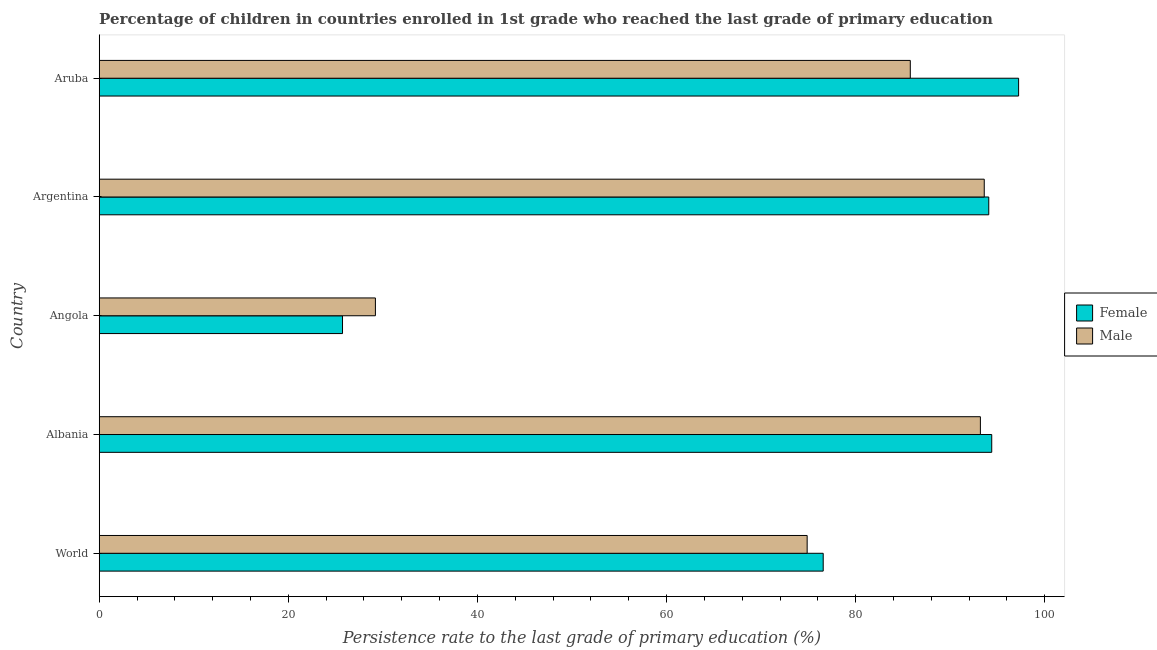Are the number of bars per tick equal to the number of legend labels?
Offer a very short reply. Yes. How many bars are there on the 5th tick from the top?
Ensure brevity in your answer.  2. How many bars are there on the 4th tick from the bottom?
Your response must be concise. 2. In how many cases, is the number of bars for a given country not equal to the number of legend labels?
Make the answer very short. 0. What is the persistence rate of female students in Albania?
Make the answer very short. 94.39. Across all countries, what is the maximum persistence rate of female students?
Give a very brief answer. 97.23. Across all countries, what is the minimum persistence rate of female students?
Provide a short and direct response. 25.73. In which country was the persistence rate of male students maximum?
Offer a terse response. Argentina. In which country was the persistence rate of male students minimum?
Make the answer very short. Angola. What is the total persistence rate of male students in the graph?
Ensure brevity in your answer.  376.64. What is the difference between the persistence rate of male students in Albania and that in World?
Provide a short and direct response. 18.32. What is the difference between the persistence rate of male students in World and the persistence rate of female students in Albania?
Keep it short and to the point. -19.52. What is the average persistence rate of female students per country?
Your response must be concise. 77.6. What is the difference between the persistence rate of male students and persistence rate of female students in Aruba?
Your answer should be very brief. -11.46. In how many countries, is the persistence rate of male students greater than 84 %?
Your answer should be very brief. 3. What is the ratio of the persistence rate of female students in Argentina to that in World?
Ensure brevity in your answer.  1.23. Is the difference between the persistence rate of male students in Argentina and Aruba greater than the difference between the persistence rate of female students in Argentina and Aruba?
Your answer should be very brief. Yes. What is the difference between the highest and the second highest persistence rate of female students?
Offer a very short reply. 2.84. What is the difference between the highest and the lowest persistence rate of female students?
Provide a short and direct response. 71.5. In how many countries, is the persistence rate of female students greater than the average persistence rate of female students taken over all countries?
Your response must be concise. 3. Is the sum of the persistence rate of male students in Albania and Angola greater than the maximum persistence rate of female students across all countries?
Provide a succinct answer. Yes. How many countries are there in the graph?
Your answer should be compact. 5. What is the difference between two consecutive major ticks on the X-axis?
Provide a succinct answer. 20. Does the graph contain any zero values?
Keep it short and to the point. No. Does the graph contain grids?
Make the answer very short. No. What is the title of the graph?
Provide a short and direct response. Percentage of children in countries enrolled in 1st grade who reached the last grade of primary education. What is the label or title of the X-axis?
Offer a very short reply. Persistence rate to the last grade of primary education (%). What is the Persistence rate to the last grade of primary education (%) in Female in World?
Provide a short and direct response. 76.57. What is the Persistence rate to the last grade of primary education (%) in Male in World?
Ensure brevity in your answer.  74.87. What is the Persistence rate to the last grade of primary education (%) of Female in Albania?
Offer a very short reply. 94.39. What is the Persistence rate to the last grade of primary education (%) in Male in Albania?
Provide a short and direct response. 93.19. What is the Persistence rate to the last grade of primary education (%) of Female in Angola?
Keep it short and to the point. 25.73. What is the Persistence rate to the last grade of primary education (%) of Male in Angola?
Your answer should be very brief. 29.21. What is the Persistence rate to the last grade of primary education (%) in Female in Argentina?
Give a very brief answer. 94.08. What is the Persistence rate to the last grade of primary education (%) of Male in Argentina?
Provide a short and direct response. 93.6. What is the Persistence rate to the last grade of primary education (%) in Female in Aruba?
Provide a succinct answer. 97.23. What is the Persistence rate to the last grade of primary education (%) in Male in Aruba?
Keep it short and to the point. 85.78. Across all countries, what is the maximum Persistence rate to the last grade of primary education (%) in Female?
Your response must be concise. 97.23. Across all countries, what is the maximum Persistence rate to the last grade of primary education (%) in Male?
Provide a short and direct response. 93.6. Across all countries, what is the minimum Persistence rate to the last grade of primary education (%) of Female?
Provide a succinct answer. 25.73. Across all countries, what is the minimum Persistence rate to the last grade of primary education (%) in Male?
Keep it short and to the point. 29.21. What is the total Persistence rate to the last grade of primary education (%) of Female in the graph?
Your answer should be compact. 387.99. What is the total Persistence rate to the last grade of primary education (%) in Male in the graph?
Keep it short and to the point. 376.64. What is the difference between the Persistence rate to the last grade of primary education (%) in Female in World and that in Albania?
Give a very brief answer. -17.82. What is the difference between the Persistence rate to the last grade of primary education (%) of Male in World and that in Albania?
Your answer should be compact. -18.32. What is the difference between the Persistence rate to the last grade of primary education (%) in Female in World and that in Angola?
Your response must be concise. 50.83. What is the difference between the Persistence rate to the last grade of primary education (%) of Male in World and that in Angola?
Ensure brevity in your answer.  45.66. What is the difference between the Persistence rate to the last grade of primary education (%) of Female in World and that in Argentina?
Offer a very short reply. -17.51. What is the difference between the Persistence rate to the last grade of primary education (%) in Male in World and that in Argentina?
Make the answer very short. -18.73. What is the difference between the Persistence rate to the last grade of primary education (%) of Female in World and that in Aruba?
Your answer should be compact. -20.67. What is the difference between the Persistence rate to the last grade of primary education (%) in Male in World and that in Aruba?
Offer a terse response. -10.91. What is the difference between the Persistence rate to the last grade of primary education (%) of Female in Albania and that in Angola?
Ensure brevity in your answer.  68.66. What is the difference between the Persistence rate to the last grade of primary education (%) in Male in Albania and that in Angola?
Provide a succinct answer. 63.98. What is the difference between the Persistence rate to the last grade of primary education (%) in Female in Albania and that in Argentina?
Ensure brevity in your answer.  0.31. What is the difference between the Persistence rate to the last grade of primary education (%) of Male in Albania and that in Argentina?
Offer a very short reply. -0.41. What is the difference between the Persistence rate to the last grade of primary education (%) of Female in Albania and that in Aruba?
Give a very brief answer. -2.84. What is the difference between the Persistence rate to the last grade of primary education (%) of Male in Albania and that in Aruba?
Provide a short and direct response. 7.41. What is the difference between the Persistence rate to the last grade of primary education (%) in Female in Angola and that in Argentina?
Make the answer very short. -68.34. What is the difference between the Persistence rate to the last grade of primary education (%) of Male in Angola and that in Argentina?
Your answer should be compact. -64.39. What is the difference between the Persistence rate to the last grade of primary education (%) in Female in Angola and that in Aruba?
Your response must be concise. -71.5. What is the difference between the Persistence rate to the last grade of primary education (%) in Male in Angola and that in Aruba?
Offer a terse response. -56.57. What is the difference between the Persistence rate to the last grade of primary education (%) of Female in Argentina and that in Aruba?
Your answer should be very brief. -3.16. What is the difference between the Persistence rate to the last grade of primary education (%) in Male in Argentina and that in Aruba?
Ensure brevity in your answer.  7.82. What is the difference between the Persistence rate to the last grade of primary education (%) in Female in World and the Persistence rate to the last grade of primary education (%) in Male in Albania?
Your response must be concise. -16.62. What is the difference between the Persistence rate to the last grade of primary education (%) in Female in World and the Persistence rate to the last grade of primary education (%) in Male in Angola?
Provide a succinct answer. 47.36. What is the difference between the Persistence rate to the last grade of primary education (%) of Female in World and the Persistence rate to the last grade of primary education (%) of Male in Argentina?
Your answer should be compact. -17.03. What is the difference between the Persistence rate to the last grade of primary education (%) in Female in World and the Persistence rate to the last grade of primary education (%) in Male in Aruba?
Your answer should be very brief. -9.21. What is the difference between the Persistence rate to the last grade of primary education (%) in Female in Albania and the Persistence rate to the last grade of primary education (%) in Male in Angola?
Ensure brevity in your answer.  65.18. What is the difference between the Persistence rate to the last grade of primary education (%) in Female in Albania and the Persistence rate to the last grade of primary education (%) in Male in Argentina?
Provide a short and direct response. 0.79. What is the difference between the Persistence rate to the last grade of primary education (%) of Female in Albania and the Persistence rate to the last grade of primary education (%) of Male in Aruba?
Provide a short and direct response. 8.61. What is the difference between the Persistence rate to the last grade of primary education (%) in Female in Angola and the Persistence rate to the last grade of primary education (%) in Male in Argentina?
Your answer should be very brief. -67.87. What is the difference between the Persistence rate to the last grade of primary education (%) in Female in Angola and the Persistence rate to the last grade of primary education (%) in Male in Aruba?
Provide a short and direct response. -60.05. What is the difference between the Persistence rate to the last grade of primary education (%) in Female in Argentina and the Persistence rate to the last grade of primary education (%) in Male in Aruba?
Offer a very short reply. 8.3. What is the average Persistence rate to the last grade of primary education (%) in Female per country?
Provide a succinct answer. 77.6. What is the average Persistence rate to the last grade of primary education (%) of Male per country?
Your answer should be compact. 75.33. What is the difference between the Persistence rate to the last grade of primary education (%) of Female and Persistence rate to the last grade of primary education (%) of Male in World?
Ensure brevity in your answer.  1.7. What is the difference between the Persistence rate to the last grade of primary education (%) in Female and Persistence rate to the last grade of primary education (%) in Male in Albania?
Provide a succinct answer. 1.2. What is the difference between the Persistence rate to the last grade of primary education (%) of Female and Persistence rate to the last grade of primary education (%) of Male in Angola?
Provide a short and direct response. -3.48. What is the difference between the Persistence rate to the last grade of primary education (%) of Female and Persistence rate to the last grade of primary education (%) of Male in Argentina?
Make the answer very short. 0.48. What is the difference between the Persistence rate to the last grade of primary education (%) of Female and Persistence rate to the last grade of primary education (%) of Male in Aruba?
Your response must be concise. 11.46. What is the ratio of the Persistence rate to the last grade of primary education (%) in Female in World to that in Albania?
Give a very brief answer. 0.81. What is the ratio of the Persistence rate to the last grade of primary education (%) in Male in World to that in Albania?
Provide a succinct answer. 0.8. What is the ratio of the Persistence rate to the last grade of primary education (%) in Female in World to that in Angola?
Your answer should be compact. 2.98. What is the ratio of the Persistence rate to the last grade of primary education (%) of Male in World to that in Angola?
Give a very brief answer. 2.56. What is the ratio of the Persistence rate to the last grade of primary education (%) in Female in World to that in Argentina?
Give a very brief answer. 0.81. What is the ratio of the Persistence rate to the last grade of primary education (%) in Male in World to that in Argentina?
Your response must be concise. 0.8. What is the ratio of the Persistence rate to the last grade of primary education (%) of Female in World to that in Aruba?
Your response must be concise. 0.79. What is the ratio of the Persistence rate to the last grade of primary education (%) in Male in World to that in Aruba?
Offer a very short reply. 0.87. What is the ratio of the Persistence rate to the last grade of primary education (%) of Female in Albania to that in Angola?
Provide a short and direct response. 3.67. What is the ratio of the Persistence rate to the last grade of primary education (%) of Male in Albania to that in Angola?
Make the answer very short. 3.19. What is the ratio of the Persistence rate to the last grade of primary education (%) of Male in Albania to that in Argentina?
Give a very brief answer. 1. What is the ratio of the Persistence rate to the last grade of primary education (%) in Female in Albania to that in Aruba?
Ensure brevity in your answer.  0.97. What is the ratio of the Persistence rate to the last grade of primary education (%) in Male in Albania to that in Aruba?
Your response must be concise. 1.09. What is the ratio of the Persistence rate to the last grade of primary education (%) of Female in Angola to that in Argentina?
Your answer should be compact. 0.27. What is the ratio of the Persistence rate to the last grade of primary education (%) in Male in Angola to that in Argentina?
Offer a very short reply. 0.31. What is the ratio of the Persistence rate to the last grade of primary education (%) of Female in Angola to that in Aruba?
Provide a succinct answer. 0.26. What is the ratio of the Persistence rate to the last grade of primary education (%) in Male in Angola to that in Aruba?
Make the answer very short. 0.34. What is the ratio of the Persistence rate to the last grade of primary education (%) in Female in Argentina to that in Aruba?
Give a very brief answer. 0.97. What is the ratio of the Persistence rate to the last grade of primary education (%) of Male in Argentina to that in Aruba?
Make the answer very short. 1.09. What is the difference between the highest and the second highest Persistence rate to the last grade of primary education (%) of Female?
Provide a short and direct response. 2.84. What is the difference between the highest and the second highest Persistence rate to the last grade of primary education (%) of Male?
Your answer should be compact. 0.41. What is the difference between the highest and the lowest Persistence rate to the last grade of primary education (%) of Female?
Give a very brief answer. 71.5. What is the difference between the highest and the lowest Persistence rate to the last grade of primary education (%) in Male?
Ensure brevity in your answer.  64.39. 